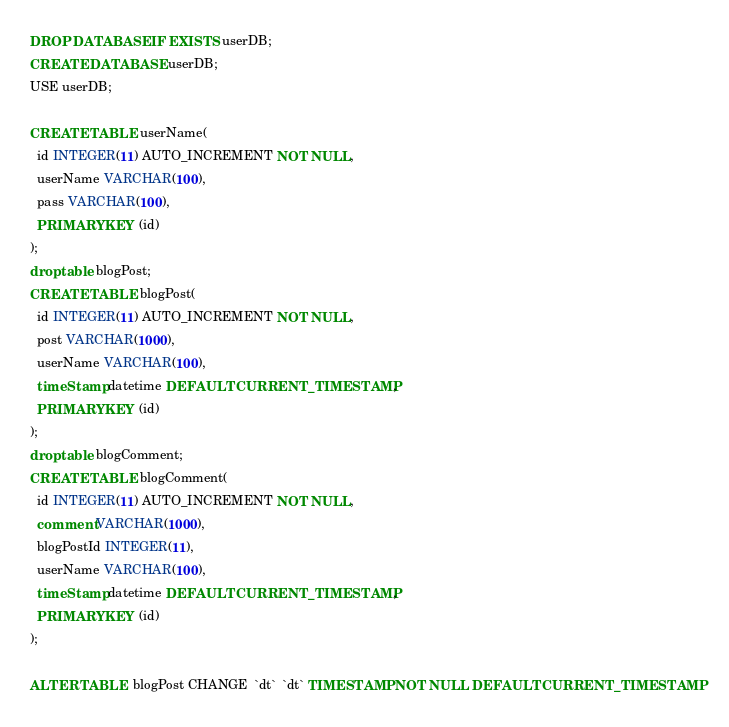<code> <loc_0><loc_0><loc_500><loc_500><_SQL_>DROP DATABASE IF EXISTS userDB;
CREATE DATABASE userDB;
USE userDB;

CREATE TABLE userName(
  id INTEGER(11) AUTO_INCREMENT NOT NULL,
  userName VARCHAR(100),
  pass VARCHAR(100),
  PRIMARY KEY (id)
);
drop table blogPost;
CREATE TABLE blogPost(
  id INTEGER(11) AUTO_INCREMENT NOT NULL,
  post VARCHAR(1000),
  userName VARCHAR(100),
  timeStamp datetime DEFAULT CURRENT_TIMESTAMP, 
  PRIMARY KEY (id)
);
drop table blogComment;
CREATE TABLE blogComment(
  id INTEGER(11) AUTO_INCREMENT NOT NULL,
  comment VARCHAR(1000),
  blogPostId INTEGER(11),
  userName VARCHAR(100),
  timeStamp datetime DEFAULT CURRENT_TIMESTAMP,
  PRIMARY KEY (id)
);

ALTER TABLE  blogPost CHANGE  `dt`  `dt` TIMESTAMP NOT NULL DEFAULT CURRENT_TIMESTAMP</code> 